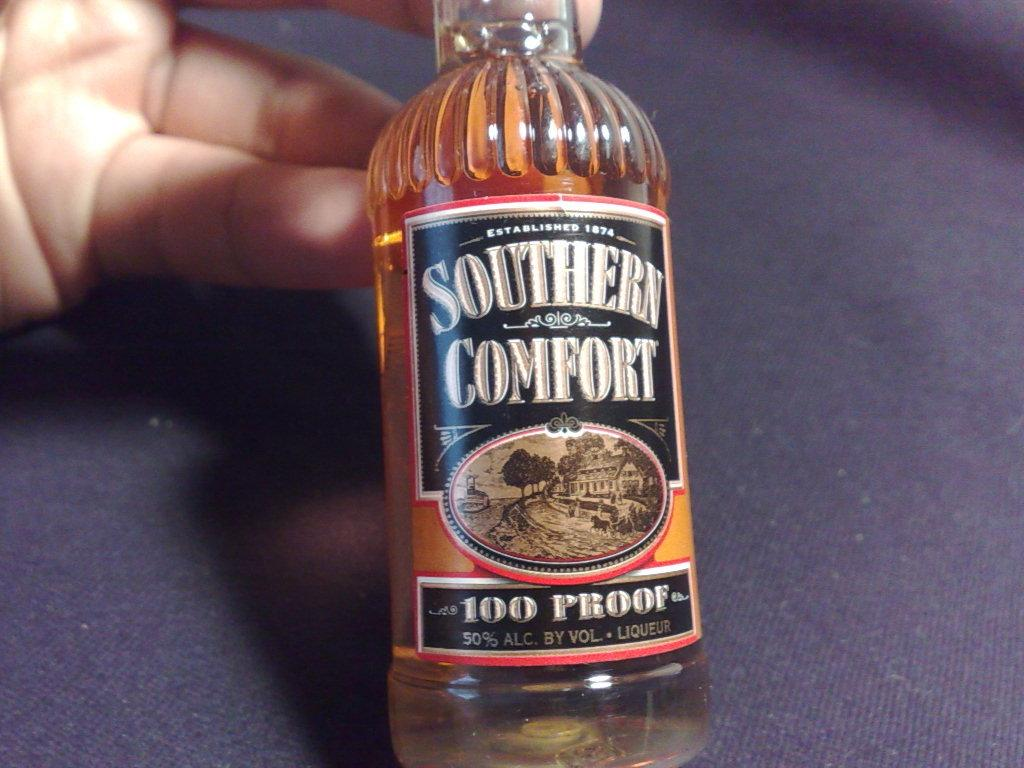Provide a one-sentence caption for the provided image. Person holding a Southern Comfort beer that is 100 Proof. 